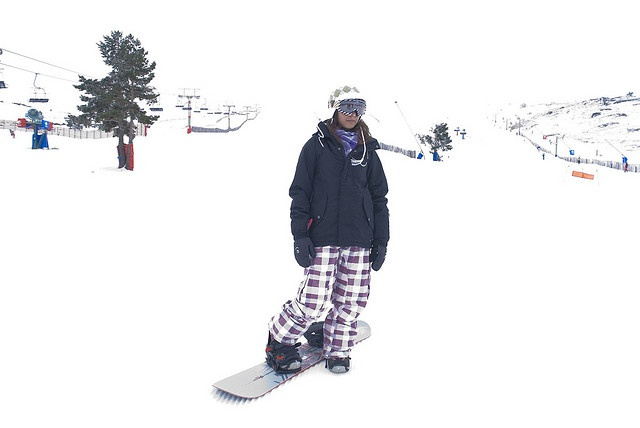Describe the objects in this image and their specific colors. I can see people in white, black, lightgray, and purple tones and snowboard in white, lightgray, gray, and darkgray tones in this image. 